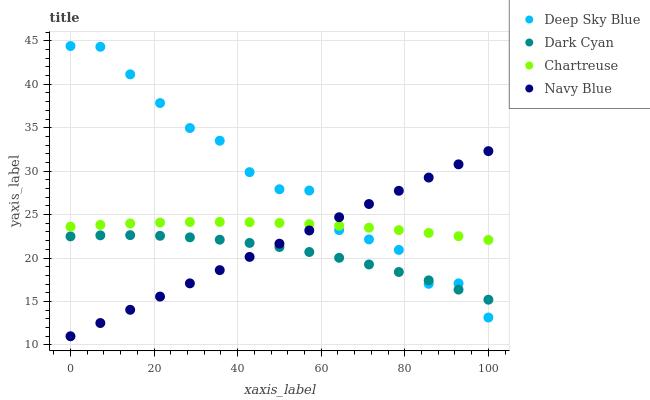Does Dark Cyan have the minimum area under the curve?
Answer yes or no. Yes. Does Deep Sky Blue have the maximum area under the curve?
Answer yes or no. Yes. Does Navy Blue have the minimum area under the curve?
Answer yes or no. No. Does Navy Blue have the maximum area under the curve?
Answer yes or no. No. Is Navy Blue the smoothest?
Answer yes or no. Yes. Is Deep Sky Blue the roughest?
Answer yes or no. Yes. Is Chartreuse the smoothest?
Answer yes or no. No. Is Chartreuse the roughest?
Answer yes or no. No. Does Navy Blue have the lowest value?
Answer yes or no. Yes. Does Chartreuse have the lowest value?
Answer yes or no. No. Does Deep Sky Blue have the highest value?
Answer yes or no. Yes. Does Navy Blue have the highest value?
Answer yes or no. No. Is Dark Cyan less than Chartreuse?
Answer yes or no. Yes. Is Chartreuse greater than Dark Cyan?
Answer yes or no. Yes. Does Deep Sky Blue intersect Chartreuse?
Answer yes or no. Yes. Is Deep Sky Blue less than Chartreuse?
Answer yes or no. No. Is Deep Sky Blue greater than Chartreuse?
Answer yes or no. No. Does Dark Cyan intersect Chartreuse?
Answer yes or no. No. 